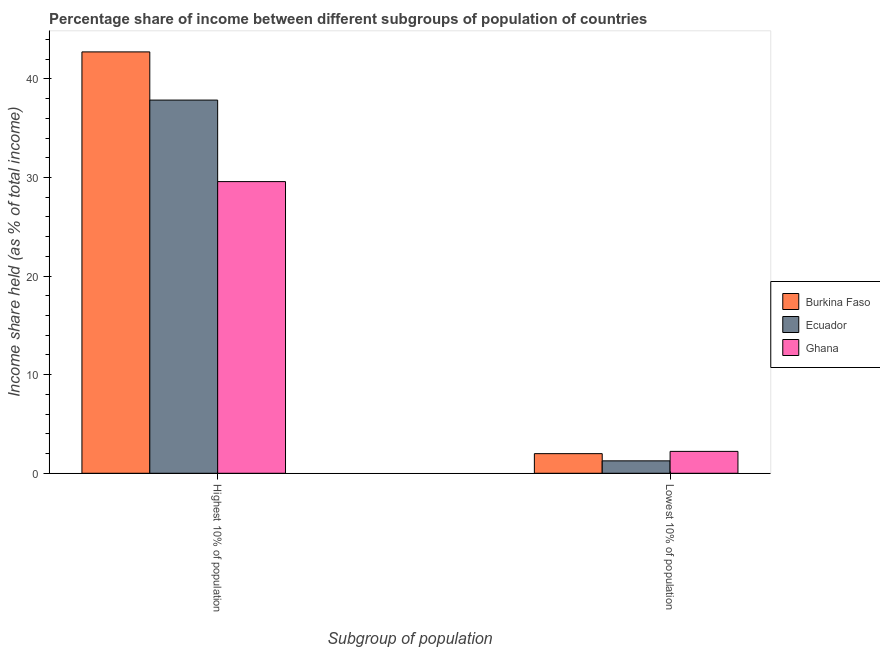How many groups of bars are there?
Your answer should be compact. 2. Are the number of bars on each tick of the X-axis equal?
Offer a very short reply. Yes. How many bars are there on the 1st tick from the left?
Give a very brief answer. 3. How many bars are there on the 1st tick from the right?
Offer a terse response. 3. What is the label of the 1st group of bars from the left?
Give a very brief answer. Highest 10% of population. What is the income share held by lowest 10% of the population in Ecuador?
Provide a short and direct response. 1.26. Across all countries, what is the maximum income share held by highest 10% of the population?
Make the answer very short. 42.75. Across all countries, what is the minimum income share held by lowest 10% of the population?
Your response must be concise. 1.26. In which country was the income share held by highest 10% of the population maximum?
Your response must be concise. Burkina Faso. In which country was the income share held by lowest 10% of the population minimum?
Ensure brevity in your answer.  Ecuador. What is the total income share held by lowest 10% of the population in the graph?
Make the answer very short. 5.47. What is the difference between the income share held by lowest 10% of the population in Burkina Faso and that in Ecuador?
Provide a succinct answer. 0.73. What is the difference between the income share held by lowest 10% of the population in Ecuador and the income share held by highest 10% of the population in Ghana?
Your response must be concise. -28.33. What is the average income share held by lowest 10% of the population per country?
Provide a succinct answer. 1.82. What is the difference between the income share held by highest 10% of the population and income share held by lowest 10% of the population in Ghana?
Your answer should be very brief. 27.37. In how many countries, is the income share held by highest 10% of the population greater than 6 %?
Provide a succinct answer. 3. What is the ratio of the income share held by highest 10% of the population in Burkina Faso to that in Ecuador?
Offer a terse response. 1.13. In how many countries, is the income share held by highest 10% of the population greater than the average income share held by highest 10% of the population taken over all countries?
Your response must be concise. 2. What does the 1st bar from the right in Highest 10% of population represents?
Your response must be concise. Ghana. How many bars are there?
Offer a very short reply. 6. Are all the bars in the graph horizontal?
Your answer should be compact. No. How many countries are there in the graph?
Ensure brevity in your answer.  3. Does the graph contain any zero values?
Provide a succinct answer. No. How many legend labels are there?
Your answer should be very brief. 3. How are the legend labels stacked?
Make the answer very short. Vertical. What is the title of the graph?
Make the answer very short. Percentage share of income between different subgroups of population of countries. Does "Cyprus" appear as one of the legend labels in the graph?
Provide a short and direct response. No. What is the label or title of the X-axis?
Give a very brief answer. Subgroup of population. What is the label or title of the Y-axis?
Your answer should be compact. Income share held (as % of total income). What is the Income share held (as % of total income) in Burkina Faso in Highest 10% of population?
Provide a short and direct response. 42.75. What is the Income share held (as % of total income) of Ecuador in Highest 10% of population?
Provide a succinct answer. 37.86. What is the Income share held (as % of total income) in Ghana in Highest 10% of population?
Your response must be concise. 29.59. What is the Income share held (as % of total income) in Burkina Faso in Lowest 10% of population?
Provide a succinct answer. 1.99. What is the Income share held (as % of total income) in Ecuador in Lowest 10% of population?
Provide a succinct answer. 1.26. What is the Income share held (as % of total income) of Ghana in Lowest 10% of population?
Ensure brevity in your answer.  2.22. Across all Subgroup of population, what is the maximum Income share held (as % of total income) of Burkina Faso?
Offer a very short reply. 42.75. Across all Subgroup of population, what is the maximum Income share held (as % of total income) of Ecuador?
Offer a very short reply. 37.86. Across all Subgroup of population, what is the maximum Income share held (as % of total income) in Ghana?
Offer a very short reply. 29.59. Across all Subgroup of population, what is the minimum Income share held (as % of total income) of Burkina Faso?
Provide a short and direct response. 1.99. Across all Subgroup of population, what is the minimum Income share held (as % of total income) of Ecuador?
Offer a terse response. 1.26. Across all Subgroup of population, what is the minimum Income share held (as % of total income) of Ghana?
Keep it short and to the point. 2.22. What is the total Income share held (as % of total income) in Burkina Faso in the graph?
Give a very brief answer. 44.74. What is the total Income share held (as % of total income) of Ecuador in the graph?
Your response must be concise. 39.12. What is the total Income share held (as % of total income) of Ghana in the graph?
Ensure brevity in your answer.  31.81. What is the difference between the Income share held (as % of total income) in Burkina Faso in Highest 10% of population and that in Lowest 10% of population?
Make the answer very short. 40.76. What is the difference between the Income share held (as % of total income) of Ecuador in Highest 10% of population and that in Lowest 10% of population?
Offer a very short reply. 36.6. What is the difference between the Income share held (as % of total income) in Ghana in Highest 10% of population and that in Lowest 10% of population?
Offer a terse response. 27.37. What is the difference between the Income share held (as % of total income) of Burkina Faso in Highest 10% of population and the Income share held (as % of total income) of Ecuador in Lowest 10% of population?
Offer a very short reply. 41.49. What is the difference between the Income share held (as % of total income) of Burkina Faso in Highest 10% of population and the Income share held (as % of total income) of Ghana in Lowest 10% of population?
Your answer should be very brief. 40.53. What is the difference between the Income share held (as % of total income) in Ecuador in Highest 10% of population and the Income share held (as % of total income) in Ghana in Lowest 10% of population?
Your answer should be compact. 35.64. What is the average Income share held (as % of total income) of Burkina Faso per Subgroup of population?
Make the answer very short. 22.37. What is the average Income share held (as % of total income) of Ecuador per Subgroup of population?
Give a very brief answer. 19.56. What is the average Income share held (as % of total income) of Ghana per Subgroup of population?
Your answer should be compact. 15.9. What is the difference between the Income share held (as % of total income) in Burkina Faso and Income share held (as % of total income) in Ecuador in Highest 10% of population?
Your answer should be compact. 4.89. What is the difference between the Income share held (as % of total income) of Burkina Faso and Income share held (as % of total income) of Ghana in Highest 10% of population?
Offer a very short reply. 13.16. What is the difference between the Income share held (as % of total income) in Ecuador and Income share held (as % of total income) in Ghana in Highest 10% of population?
Your response must be concise. 8.27. What is the difference between the Income share held (as % of total income) in Burkina Faso and Income share held (as % of total income) in Ecuador in Lowest 10% of population?
Your answer should be compact. 0.73. What is the difference between the Income share held (as % of total income) of Burkina Faso and Income share held (as % of total income) of Ghana in Lowest 10% of population?
Your answer should be very brief. -0.23. What is the difference between the Income share held (as % of total income) of Ecuador and Income share held (as % of total income) of Ghana in Lowest 10% of population?
Your response must be concise. -0.96. What is the ratio of the Income share held (as % of total income) of Burkina Faso in Highest 10% of population to that in Lowest 10% of population?
Provide a succinct answer. 21.48. What is the ratio of the Income share held (as % of total income) of Ecuador in Highest 10% of population to that in Lowest 10% of population?
Offer a very short reply. 30.05. What is the ratio of the Income share held (as % of total income) of Ghana in Highest 10% of population to that in Lowest 10% of population?
Your answer should be compact. 13.33. What is the difference between the highest and the second highest Income share held (as % of total income) in Burkina Faso?
Provide a short and direct response. 40.76. What is the difference between the highest and the second highest Income share held (as % of total income) in Ecuador?
Ensure brevity in your answer.  36.6. What is the difference between the highest and the second highest Income share held (as % of total income) of Ghana?
Provide a succinct answer. 27.37. What is the difference between the highest and the lowest Income share held (as % of total income) of Burkina Faso?
Provide a short and direct response. 40.76. What is the difference between the highest and the lowest Income share held (as % of total income) in Ecuador?
Your response must be concise. 36.6. What is the difference between the highest and the lowest Income share held (as % of total income) in Ghana?
Your answer should be compact. 27.37. 